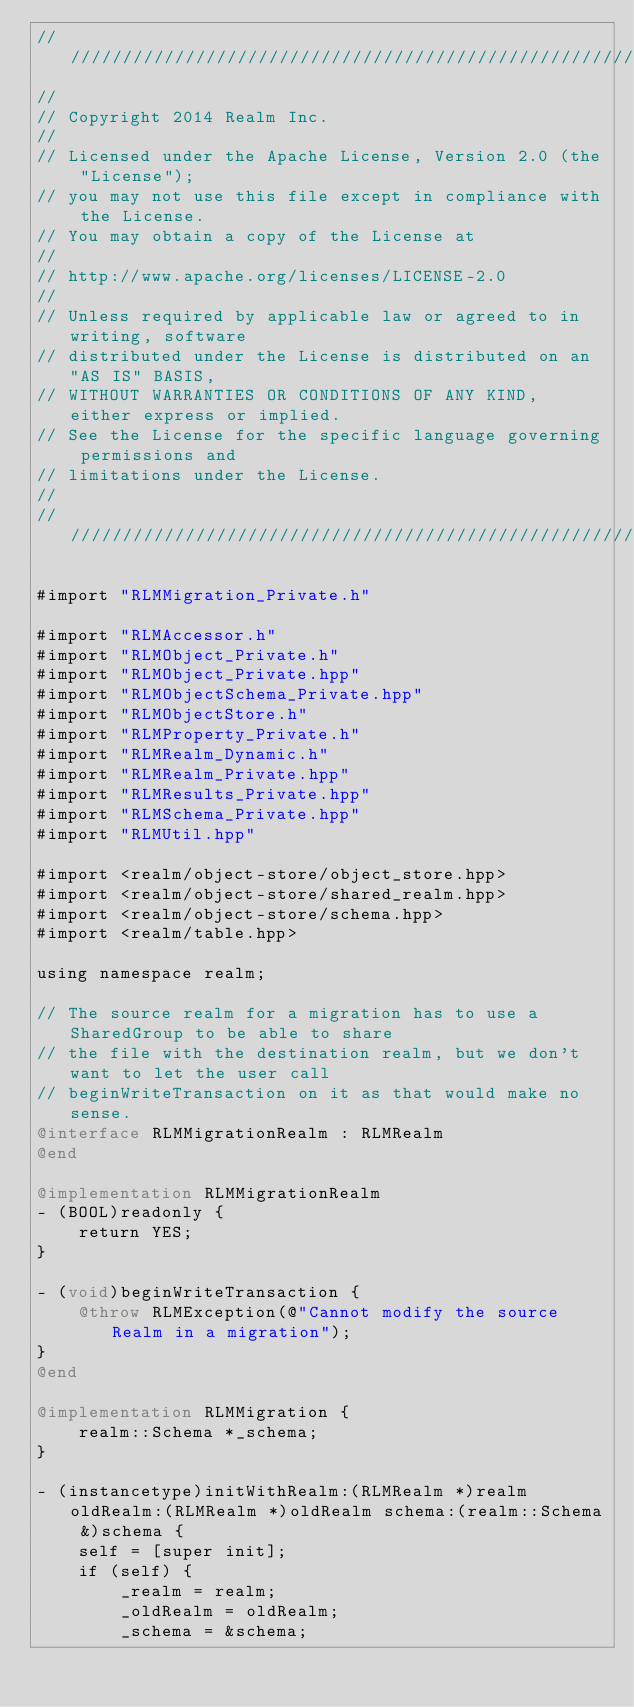<code> <loc_0><loc_0><loc_500><loc_500><_ObjectiveC_>////////////////////////////////////////////////////////////////////////////
//
// Copyright 2014 Realm Inc.
//
// Licensed under the Apache License, Version 2.0 (the "License");
// you may not use this file except in compliance with the License.
// You may obtain a copy of the License at
//
// http://www.apache.org/licenses/LICENSE-2.0
//
// Unless required by applicable law or agreed to in writing, software
// distributed under the License is distributed on an "AS IS" BASIS,
// WITHOUT WARRANTIES OR CONDITIONS OF ANY KIND, either express or implied.
// See the License for the specific language governing permissions and
// limitations under the License.
//
////////////////////////////////////////////////////////////////////////////

#import "RLMMigration_Private.h"

#import "RLMAccessor.h"
#import "RLMObject_Private.h"
#import "RLMObject_Private.hpp"
#import "RLMObjectSchema_Private.hpp"
#import "RLMObjectStore.h"
#import "RLMProperty_Private.h"
#import "RLMRealm_Dynamic.h"
#import "RLMRealm_Private.hpp"
#import "RLMResults_Private.hpp"
#import "RLMSchema_Private.hpp"
#import "RLMUtil.hpp"

#import <realm/object-store/object_store.hpp>
#import <realm/object-store/shared_realm.hpp>
#import <realm/object-store/schema.hpp>
#import <realm/table.hpp>

using namespace realm;

// The source realm for a migration has to use a SharedGroup to be able to share
// the file with the destination realm, but we don't want to let the user call
// beginWriteTransaction on it as that would make no sense.
@interface RLMMigrationRealm : RLMRealm
@end

@implementation RLMMigrationRealm
- (BOOL)readonly {
    return YES;
}

- (void)beginWriteTransaction {
    @throw RLMException(@"Cannot modify the source Realm in a migration");
}
@end

@implementation RLMMigration {
    realm::Schema *_schema;
}

- (instancetype)initWithRealm:(RLMRealm *)realm oldRealm:(RLMRealm *)oldRealm schema:(realm::Schema &)schema {
    self = [super init];
    if (self) {
        _realm = realm;
        _oldRealm = oldRealm;
        _schema = &schema;</code> 